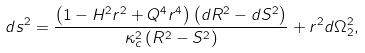<formula> <loc_0><loc_0><loc_500><loc_500>d s ^ { 2 } = \frac { \left ( 1 - H ^ { 2 } r ^ { 2 } + Q ^ { 4 } r ^ { 4 } \right ) \left ( d R ^ { 2 } - d S ^ { 2 } \right ) } { \kappa _ { c } ^ { 2 } \left ( R ^ { 2 } - S ^ { 2 } \right ) } + r ^ { 2 } d \Omega _ { 2 } ^ { 2 } ,</formula> 